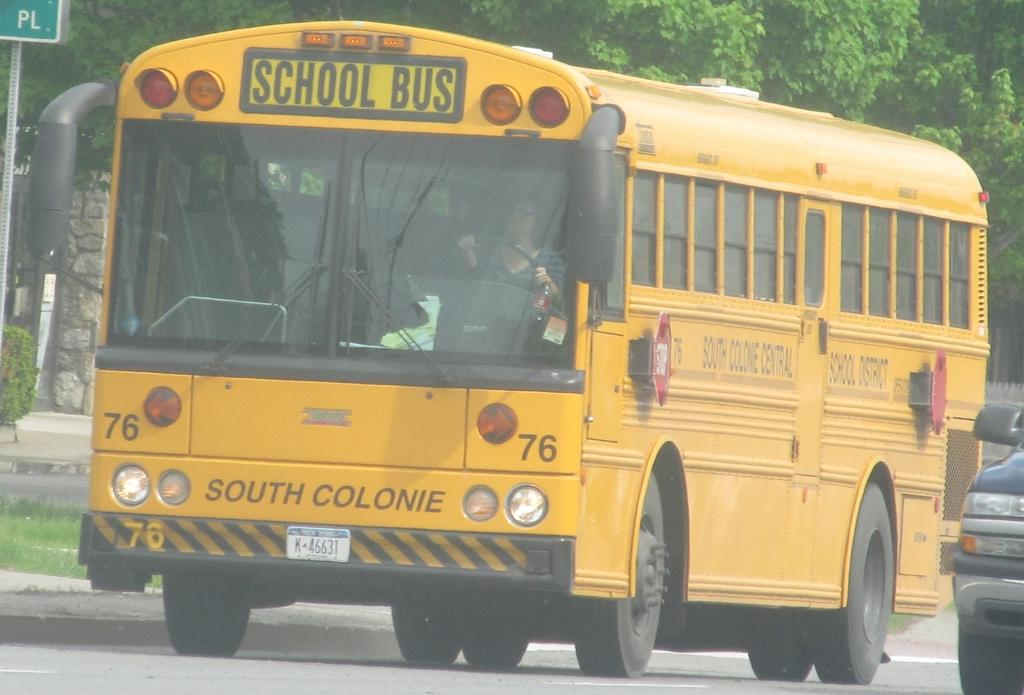Provide a one-sentence caption for the provided image. A school bus showing the driver inside, driving through a neighborhood street. 